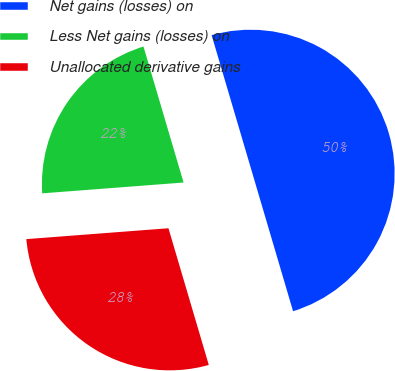Convert chart. <chart><loc_0><loc_0><loc_500><loc_500><pie_chart><fcel>Net gains (losses) on<fcel>Less Net gains (losses) on<fcel>Unallocated derivative gains<nl><fcel>50.0%<fcel>21.65%<fcel>28.35%<nl></chart> 